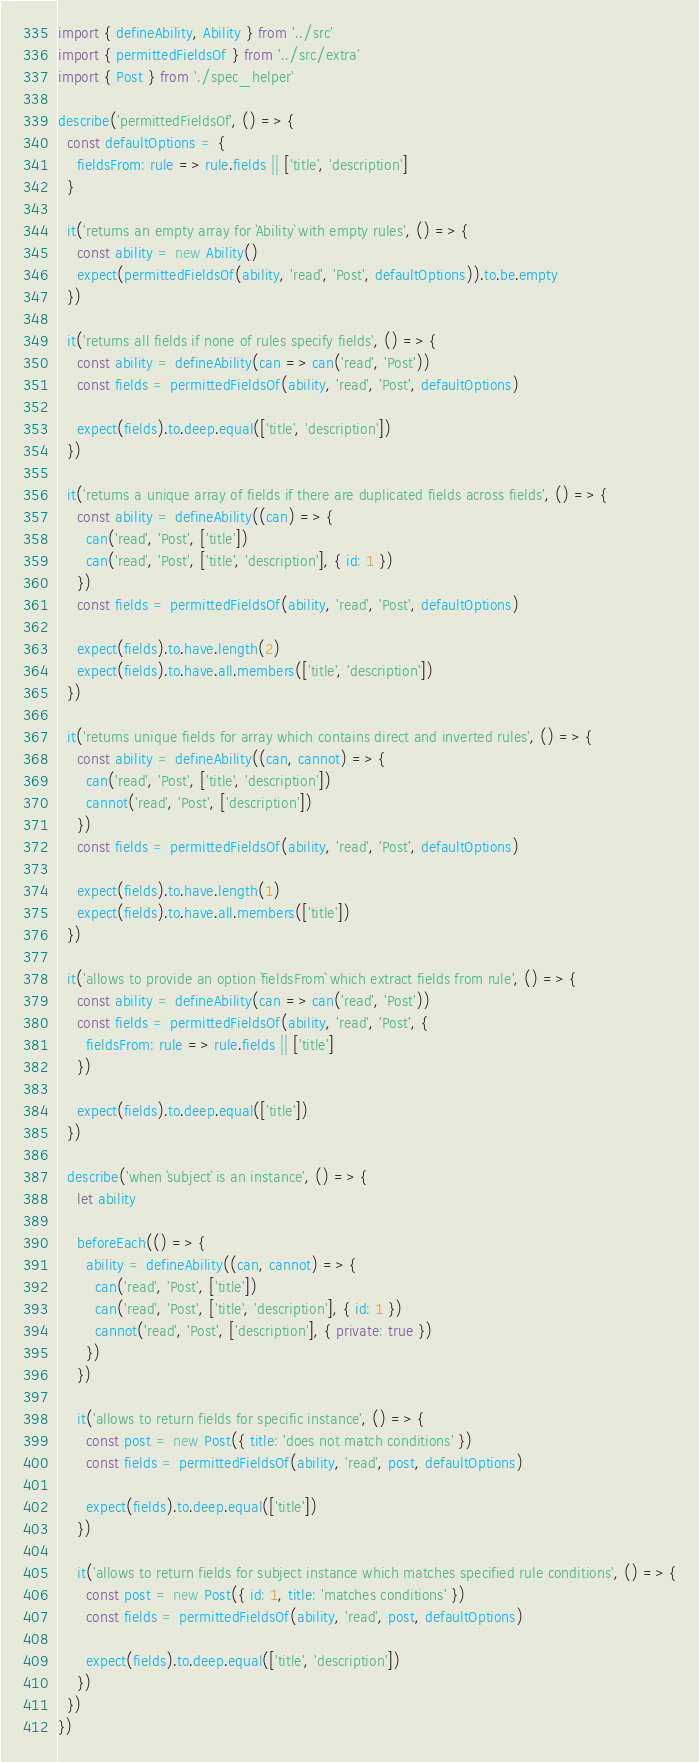Convert code to text. <code><loc_0><loc_0><loc_500><loc_500><_JavaScript_>import { defineAbility, Ability } from '../src'
import { permittedFieldsOf } from '../src/extra'
import { Post } from './spec_helper'

describe('permittedFieldsOf', () => {
  const defaultOptions = {
    fieldsFrom: rule => rule.fields || ['title', 'description']
  }

  it('returns an empty array for `Ability` with empty rules', () => {
    const ability = new Ability()
    expect(permittedFieldsOf(ability, 'read', 'Post', defaultOptions)).to.be.empty
  })

  it('returns all fields if none of rules specify fields', () => {
    const ability = defineAbility(can => can('read', 'Post'))
    const fields = permittedFieldsOf(ability, 'read', 'Post', defaultOptions)

    expect(fields).to.deep.equal(['title', 'description'])
  })

  it('returns a unique array of fields if there are duplicated fields across fields', () => {
    const ability = defineAbility((can) => {
      can('read', 'Post', ['title'])
      can('read', 'Post', ['title', 'description'], { id: 1 })
    })
    const fields = permittedFieldsOf(ability, 'read', 'Post', defaultOptions)

    expect(fields).to.have.length(2)
    expect(fields).to.have.all.members(['title', 'description'])
  })

  it('returns unique fields for array which contains direct and inverted rules', () => {
    const ability = defineAbility((can, cannot) => {
      can('read', 'Post', ['title', 'description'])
      cannot('read', 'Post', ['description'])
    })
    const fields = permittedFieldsOf(ability, 'read', 'Post', defaultOptions)

    expect(fields).to.have.length(1)
    expect(fields).to.have.all.members(['title'])
  })

  it('allows to provide an option `fieldsFrom` which extract fields from rule', () => {
    const ability = defineAbility(can => can('read', 'Post'))
    const fields = permittedFieldsOf(ability, 'read', 'Post', {
      fieldsFrom: rule => rule.fields || ['title']
    })

    expect(fields).to.deep.equal(['title'])
  })

  describe('when `subject` is an instance', () => {
    let ability

    beforeEach(() => {
      ability = defineAbility((can, cannot) => {
        can('read', 'Post', ['title'])
        can('read', 'Post', ['title', 'description'], { id: 1 })
        cannot('read', 'Post', ['description'], { private: true })
      })
    })

    it('allows to return fields for specific instance', () => {
      const post = new Post({ title: 'does not match conditions' })
      const fields = permittedFieldsOf(ability, 'read', post, defaultOptions)

      expect(fields).to.deep.equal(['title'])
    })

    it('allows to return fields for subject instance which matches specified rule conditions', () => {
      const post = new Post({ id: 1, title: 'matches conditions' })
      const fields = permittedFieldsOf(ability, 'read', post, defaultOptions)

      expect(fields).to.deep.equal(['title', 'description'])
    })
  })
})
</code> 